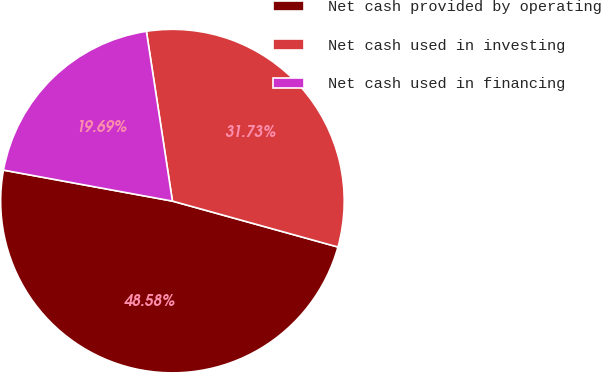Convert chart to OTSL. <chart><loc_0><loc_0><loc_500><loc_500><pie_chart><fcel>Net cash provided by operating<fcel>Net cash used in investing<fcel>Net cash used in financing<nl><fcel>48.58%<fcel>31.73%<fcel>19.69%<nl></chart> 